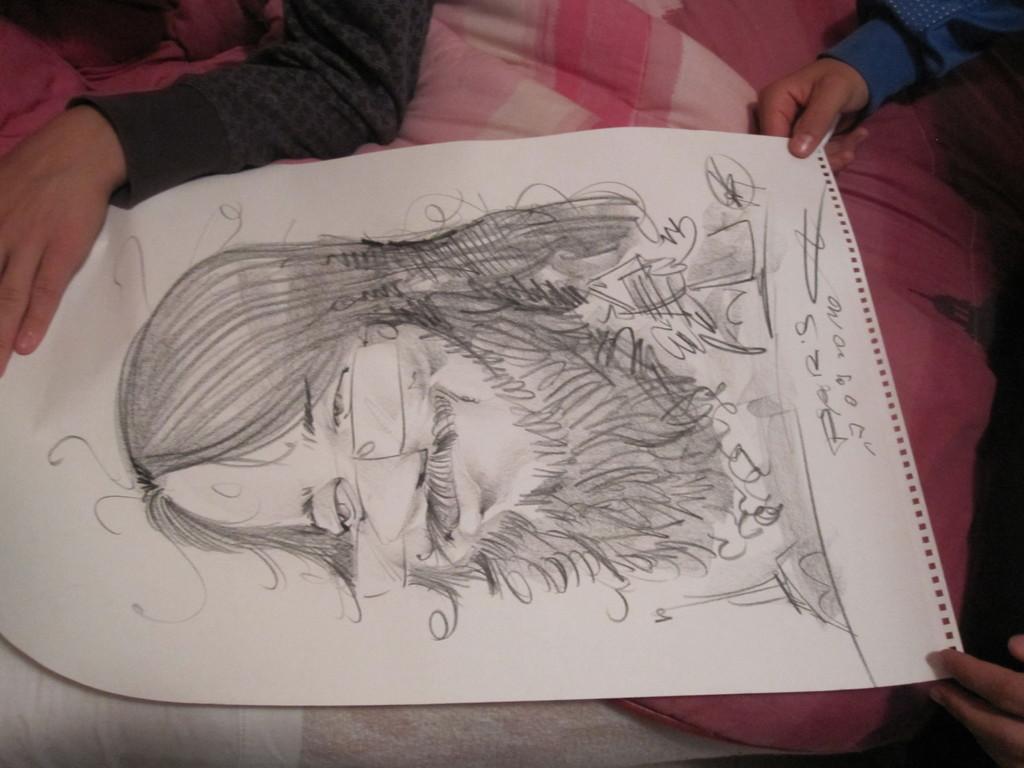How would you summarize this image in a sentence or two? We can see people hands holding a paper,on this paper we can see drawing of a person and we can see cloth. 